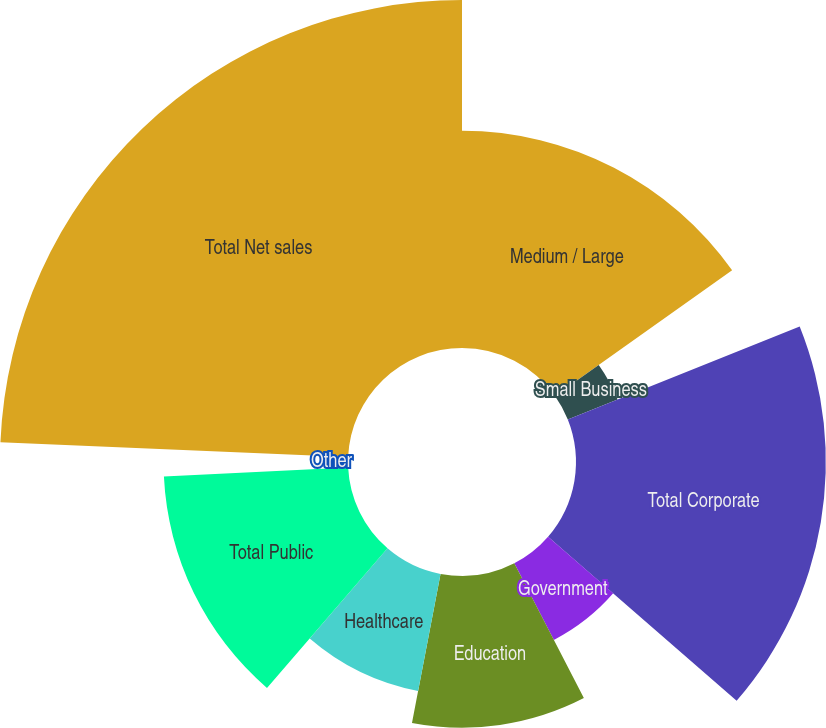Convert chart. <chart><loc_0><loc_0><loc_500><loc_500><pie_chart><fcel>Medium / Large<fcel>Small Business<fcel>Total Corporate<fcel>Government<fcel>Education<fcel>Healthcare<fcel>Total Public<fcel>Other<fcel>Total Net sales<nl><fcel>15.18%<fcel>3.75%<fcel>17.46%<fcel>6.03%<fcel>10.6%<fcel>8.32%<fcel>12.89%<fcel>1.46%<fcel>24.32%<nl></chart> 